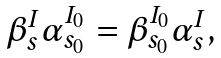Convert formula to latex. <formula><loc_0><loc_0><loc_500><loc_500>\begin{array} { l } \beta _ { s } ^ { I } \alpha _ { s _ { 0 } } ^ { I _ { 0 } } = \beta _ { s _ { 0 } } ^ { I _ { 0 } } \alpha _ { s } ^ { I } , \end{array}</formula> 